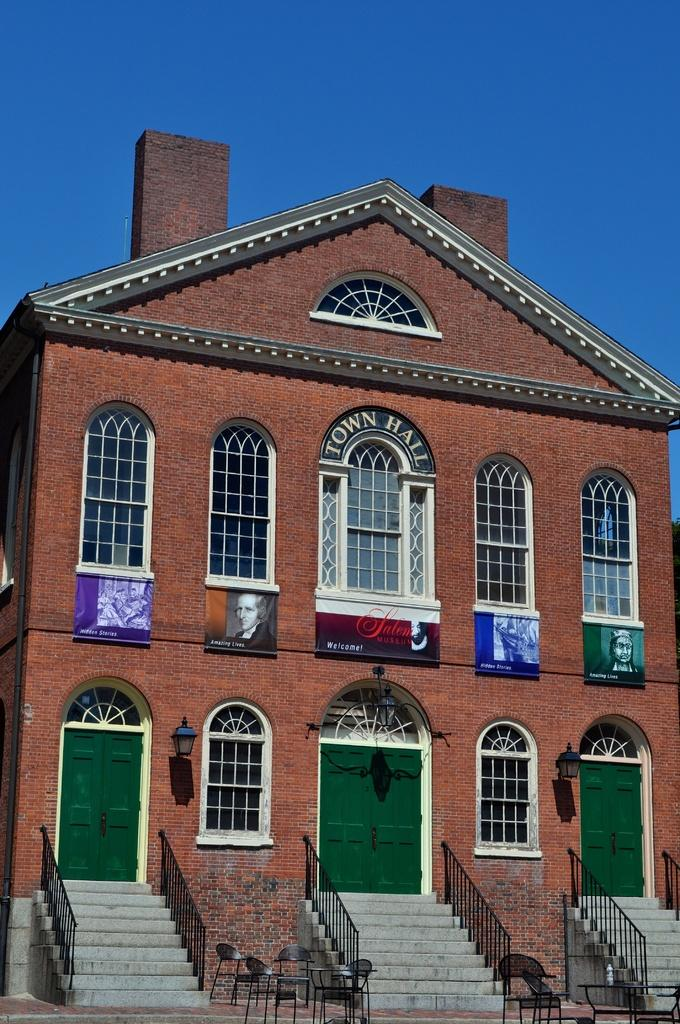What type of structure is in the picture? There is a house in the picture. What can be seen illuminating the scene? There are lights in the picture. What decorative elements are present in the picture? Banners are present in the picture. What type of furniture is visible in the picture? Chairs are visible in the picture. What architectural feature is present in the picture? There are stairs in the picture. What type of barrier is in the picture? Iron grills are in the picture. What can be seen in the background of the picture? The sky is visible in the background of the picture. What language is spoken by the wax figure in the picture? There is no wax figure present in the picture, so it is not possible to determine what language might be spoken. 